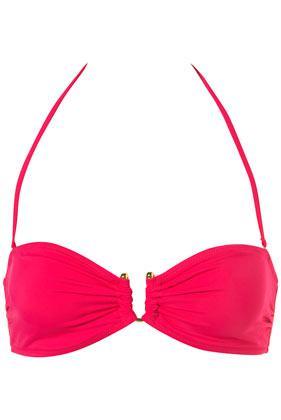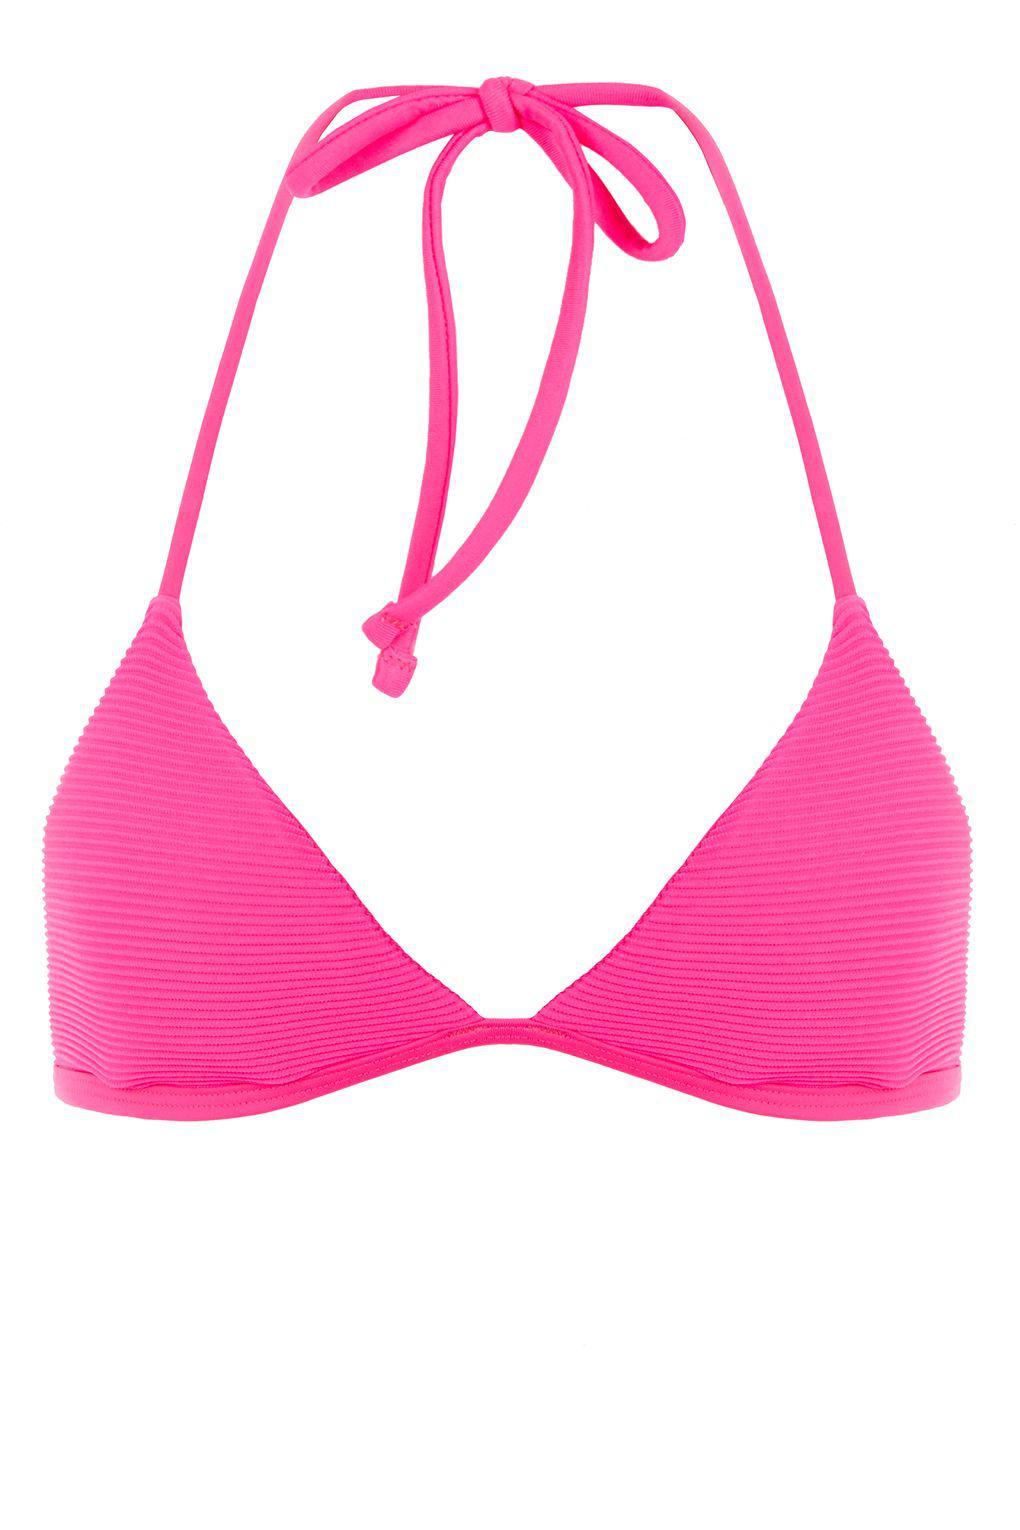The first image is the image on the left, the second image is the image on the right. Considering the images on both sides, is "The images show only brightly colored bikini tops that tie halter-style." valid? Answer yes or no. Yes. 